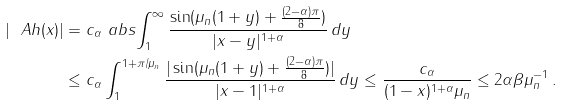Convert formula to latex. <formula><loc_0><loc_0><loc_500><loc_500>| \ A h ( x ) | & = c _ { \alpha } \ a b s { \int _ { 1 } ^ { \infty } \frac { \sin ( \mu _ { n } ( 1 + y ) + \frac { ( 2 - \alpha ) \pi } { 8 } ) } { | x - y | ^ { 1 + \alpha } } \, d y } \\ & \leq c _ { \alpha } \int _ { 1 } ^ { 1 + \pi / \mu _ { n } } \frac { | \sin ( \mu _ { n } ( 1 + y ) + \frac { ( 2 - \alpha ) \pi } { 8 } ) | } { | x - 1 | ^ { 1 + \alpha } } \, d y \leq \frac { c _ { \alpha } } { ( 1 - x ) ^ { 1 + \alpha } \mu _ { n } } \leq 2 \alpha \beta \mu _ { n } ^ { - 1 } \, .</formula> 